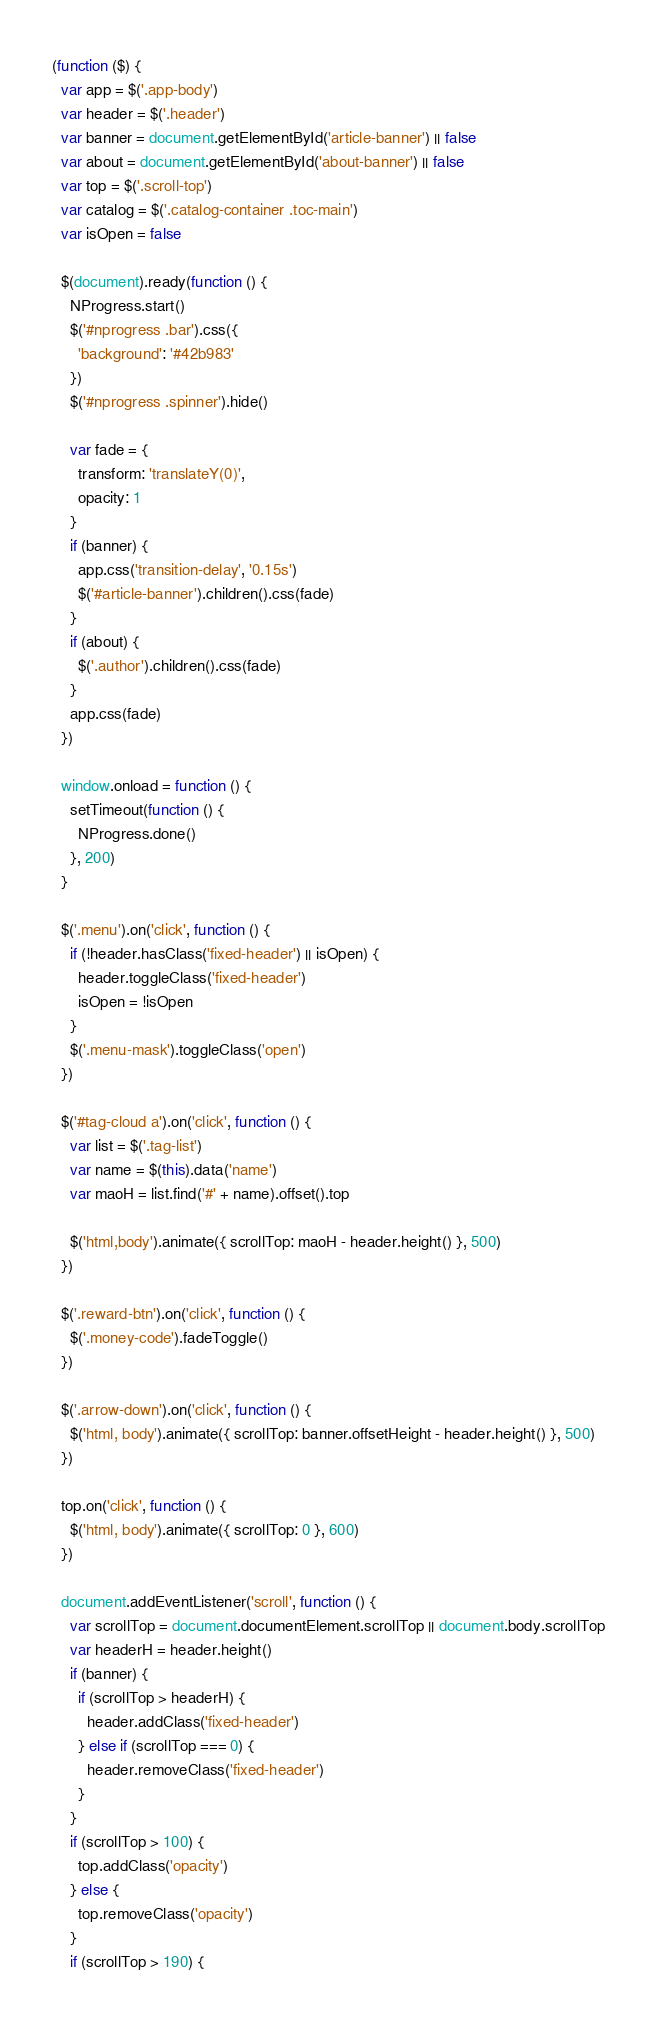Convert code to text. <code><loc_0><loc_0><loc_500><loc_500><_JavaScript_>(function ($) {
  var app = $('.app-body')
  var header = $('.header')
  var banner = document.getElementById('article-banner') || false
  var about = document.getElementById('about-banner') || false
  var top = $('.scroll-top')
  var catalog = $('.catalog-container .toc-main')
  var isOpen = false

  $(document).ready(function () {
    NProgress.start()
    $('#nprogress .bar').css({
      'background': '#42b983'
    })
    $('#nprogress .spinner').hide()

    var fade = {
      transform: 'translateY(0)',
      opacity: 1
    }
    if (banner) {
      app.css('transition-delay', '0.15s')
      $('#article-banner').children().css(fade)
    }
    if (about) {
      $('.author').children().css(fade)
    }
    app.css(fade)
  })

  window.onload = function () {
    setTimeout(function () {
      NProgress.done()
    }, 200)
  }

  $('.menu').on('click', function () {
    if (!header.hasClass('fixed-header') || isOpen) {
      header.toggleClass('fixed-header')
      isOpen = !isOpen
    }
    $('.menu-mask').toggleClass('open')
  })

  $('#tag-cloud a').on('click', function () {
    var list = $('.tag-list')
    var name = $(this).data('name')
    var maoH = list.find('#' + name).offset().top

    $('html,body').animate({ scrollTop: maoH - header.height() }, 500)
  })

  $('.reward-btn').on('click', function () {
    $('.money-code').fadeToggle()
  })

  $('.arrow-down').on('click', function () {
    $('html, body').animate({ scrollTop: banner.offsetHeight - header.height() }, 500)
  })

  top.on('click', function () {
    $('html, body').animate({ scrollTop: 0 }, 600)
  })

  document.addEventListener('scroll', function () {
    var scrollTop = document.documentElement.scrollTop || document.body.scrollTop
    var headerH = header.height()
    if (banner) {
      if (scrollTop > headerH) {
        header.addClass('fixed-header')
      } else if (scrollTop === 0) {
        header.removeClass('fixed-header')
      }
    }
    if (scrollTop > 100) {
      top.addClass('opacity')
    } else {
      top.removeClass('opacity')
    }
    if (scrollTop > 190) {</code> 